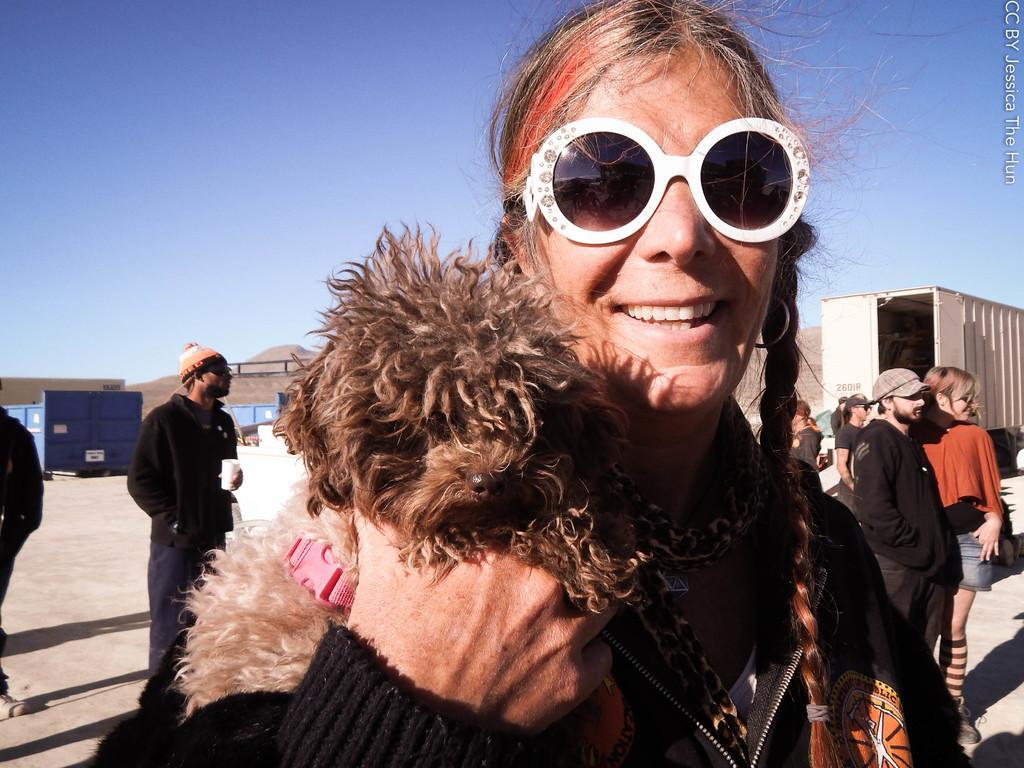How would you summarize this image in a sentence or two? In this picture a woman is highlighted. She wore white colour goggles and her hair is light brown in colour and on the background we can see blue colour sky and vehicles. Behind to this woman there are few persons standing. 